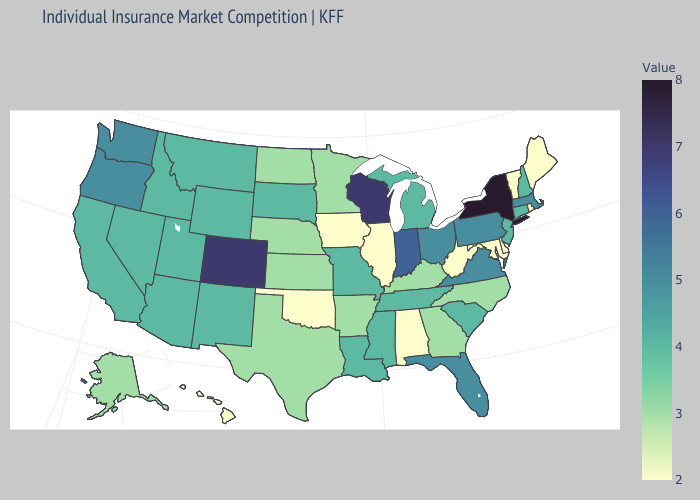Does Hawaii have the lowest value in the West?
Write a very short answer. Yes. Does Kentucky have a lower value than Delaware?
Short answer required. No. Which states have the lowest value in the USA?
Give a very brief answer. Alabama, Delaware, Hawaii, Illinois, Iowa, Maine, Maryland, Oklahoma, Rhode Island, Vermont, West Virginia. Does Missouri have a higher value than Georgia?
Keep it brief. Yes. Which states hav the highest value in the MidWest?
Answer briefly. Wisconsin. Does North Carolina have the highest value in the USA?
Be succinct. No. 